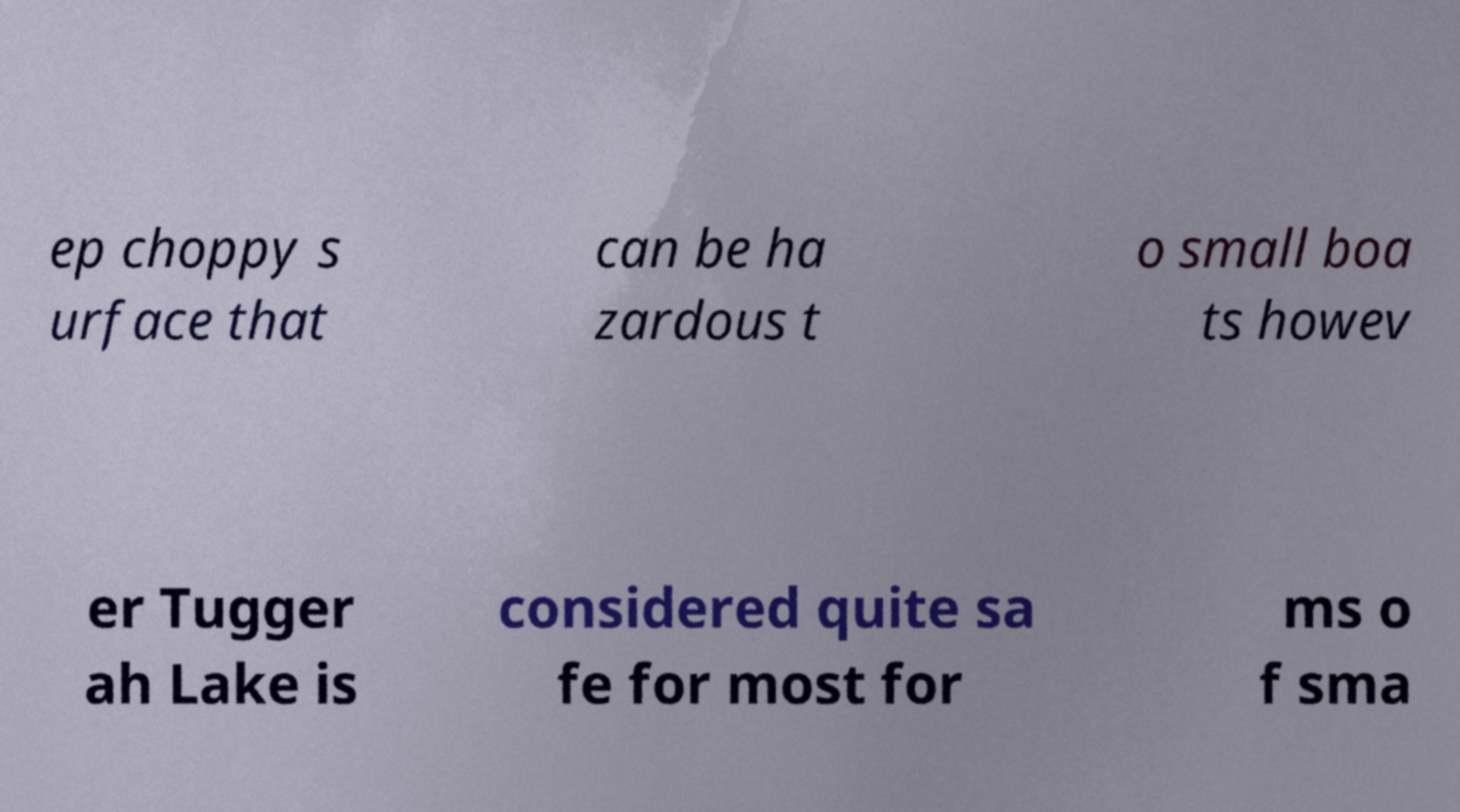Could you assist in decoding the text presented in this image and type it out clearly? ep choppy s urface that can be ha zardous t o small boa ts howev er Tugger ah Lake is considered quite sa fe for most for ms o f sma 